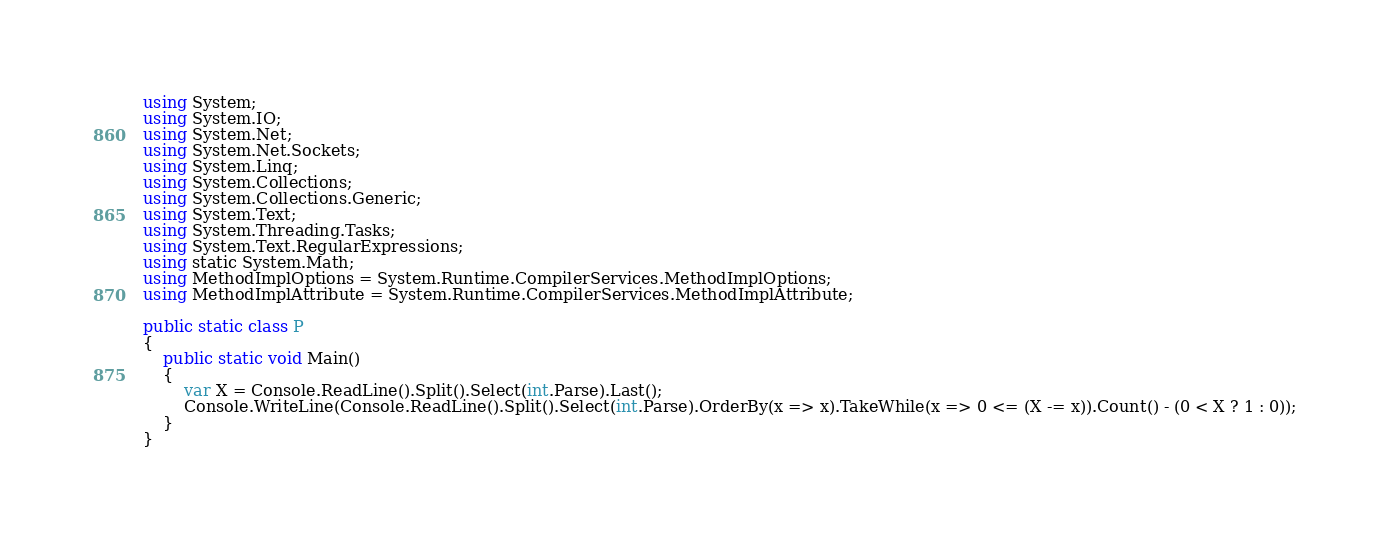Convert code to text. <code><loc_0><loc_0><loc_500><loc_500><_C#_>using System;
using System.IO;
using System.Net;
using System.Net.Sockets;
using System.Linq;
using System.Collections;
using System.Collections.Generic;
using System.Text;
using System.Threading.Tasks;
using System.Text.RegularExpressions;
using static System.Math;
using MethodImplOptions = System.Runtime.CompilerServices.MethodImplOptions;
using MethodImplAttribute = System.Runtime.CompilerServices.MethodImplAttribute;

public static class P
{
    public static void Main()
    {
        var X = Console.ReadLine().Split().Select(int.Parse).Last();
        Console.WriteLine(Console.ReadLine().Split().Select(int.Parse).OrderBy(x => x).TakeWhile(x => 0 <= (X -= x)).Count() - (0 < X ? 1 : 0));
    }
}
</code> 